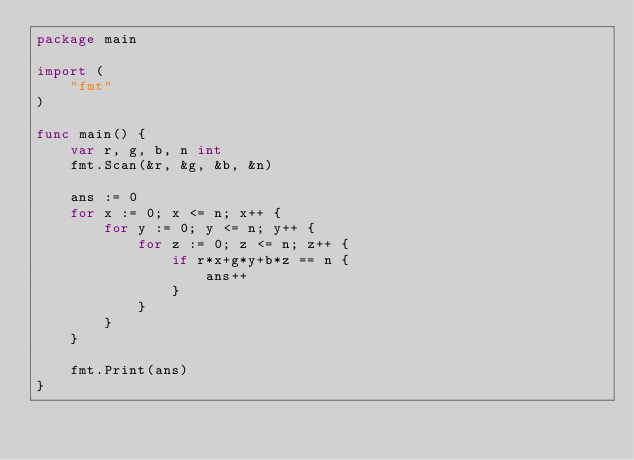Convert code to text. <code><loc_0><loc_0><loc_500><loc_500><_Go_>package main

import (
	"fmt"
)

func main() {
	var r, g, b, n int
	fmt.Scan(&r, &g, &b, &n)

	ans := 0
	for x := 0; x <= n; x++ {
		for y := 0; y <= n; y++ {
			for z := 0; z <= n; z++ {
				if r*x+g*y+b*z == n {
					ans++
				}
			}
		}
	}

	fmt.Print(ans)
}
</code> 